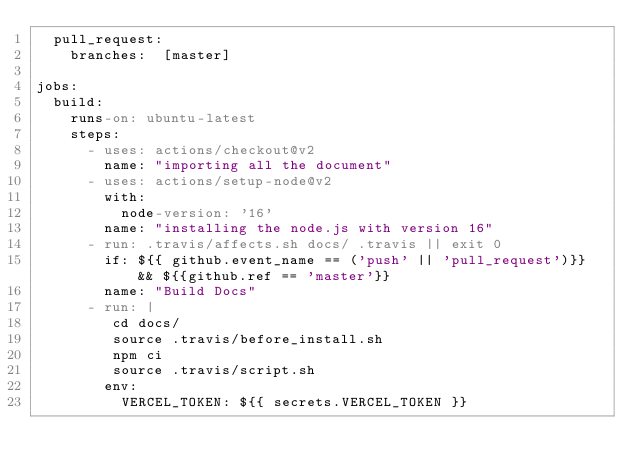Convert code to text. <code><loc_0><loc_0><loc_500><loc_500><_YAML_>  pull_request:
    branches:  [master]

jobs:
  build: 
    runs-on: ubuntu-latest
    steps:
      - uses: actions/checkout@v2
        name: "importing all the document"
      - uses: actions/setup-node@v2
        with:
          node-version: '16'
        name: "installing the node.js with version 16"
      - run: .travis/affects.sh docs/ .travis || exit 0
        if: ${{ github.event_name == ('push' || 'pull_request')}} && ${{github.ref == 'master'}}
        name: "Build Docs"
      - run: |
         cd docs/
         source .travis/before_install.sh
         npm ci
         source .travis/script.sh
        env:
          VERCEL_TOKEN: ${{ secrets.VERCEL_TOKEN }}
 

</code> 